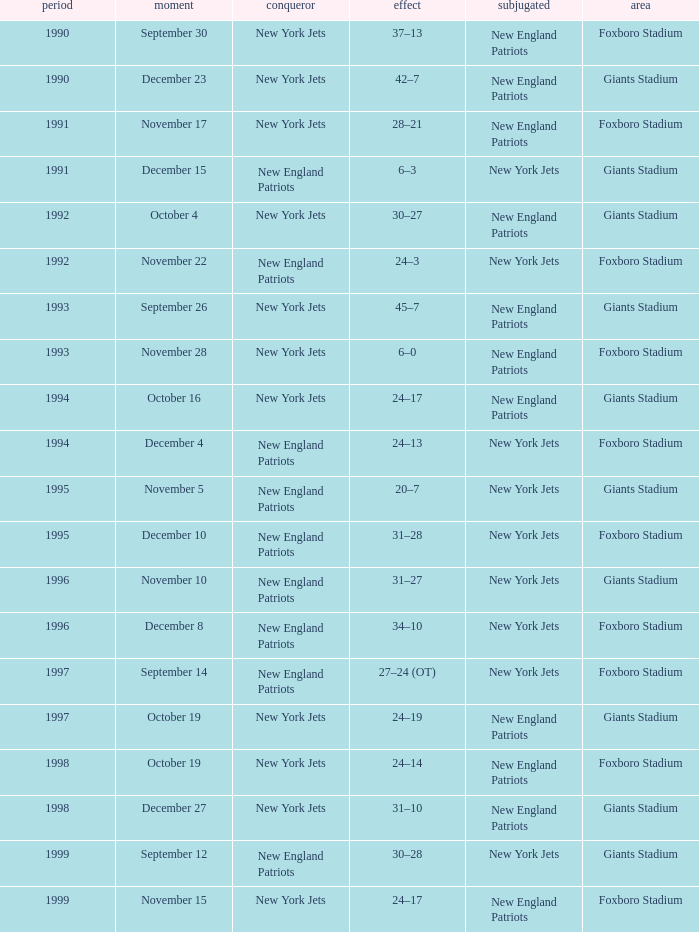What is the location when the new york jets lost earlier than 1997 and a Result of 31–28? Foxboro Stadium. 